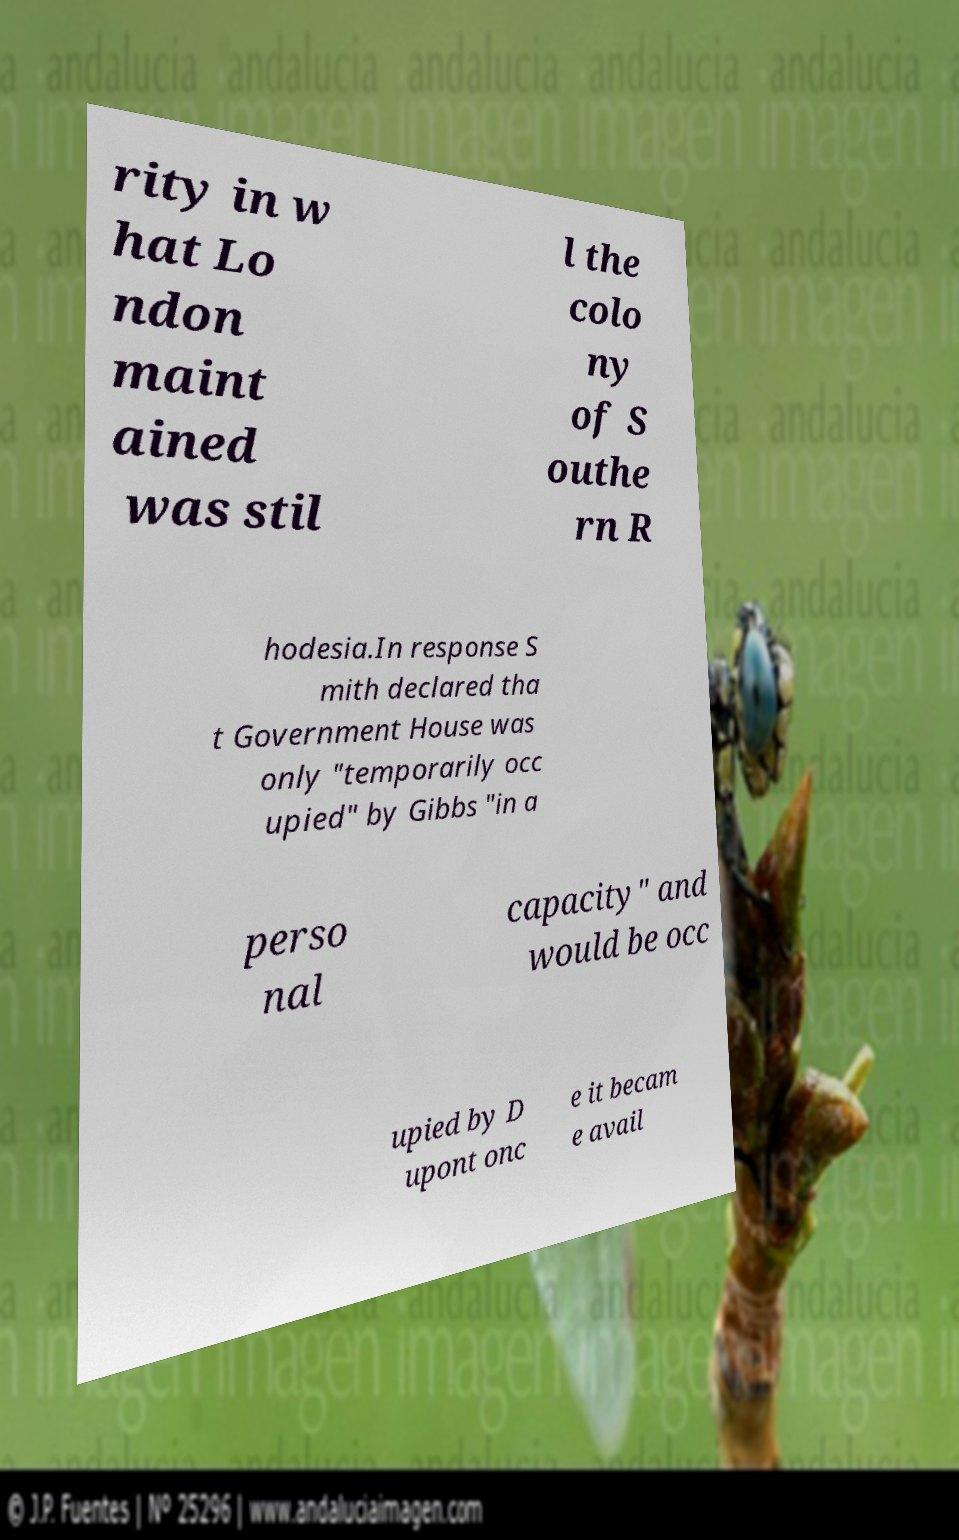Can you read and provide the text displayed in the image?This photo seems to have some interesting text. Can you extract and type it out for me? rity in w hat Lo ndon maint ained was stil l the colo ny of S outhe rn R hodesia.In response S mith declared tha t Government House was only "temporarily occ upied" by Gibbs "in a perso nal capacity" and would be occ upied by D upont onc e it becam e avail 